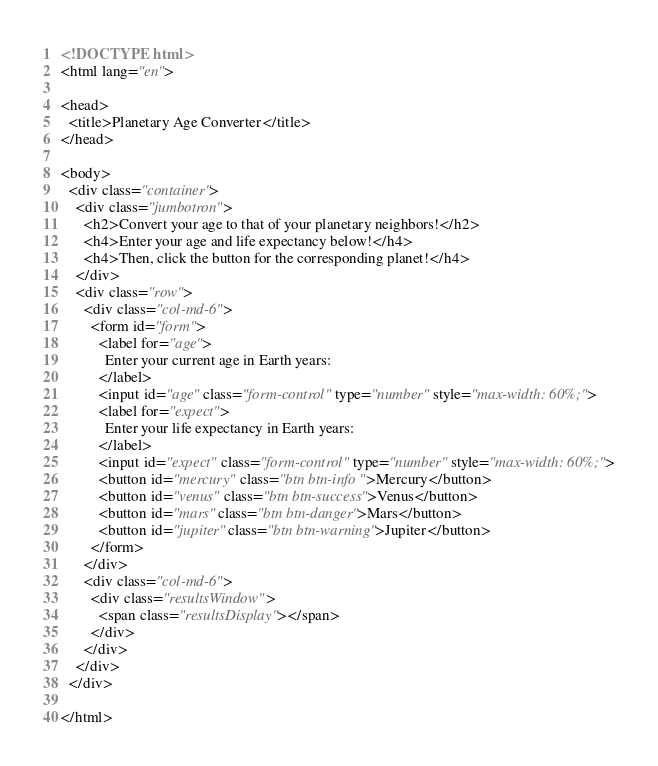Convert code to text. <code><loc_0><loc_0><loc_500><loc_500><_HTML_><!DOCTYPE html>
<html lang="en">

<head>
  <title>Planetary Age Converter</title>
</head>

<body>
  <div class="container">
    <div class="jumbotron">
      <h2>Convert your age to that of your planetary neighbors!</h2>
      <h4>Enter your age and life expectancy below!</h4>
      <h4>Then, click the button for the corresponding planet!</h4>
    </div>
    <div class="row">
      <div class="col-md-6">
        <form id="form">
          <label for="age">
            Enter your current age in Earth years:
          </label>
          <input id="age" class="form-control" type="number" style="max-width: 60%;">
          <label for="expect">
            Enter your life expectancy in Earth years:
          </label>
          <input id="expect" class="form-control" type="number" style="max-width: 60%;">
          <button id="mercury" class="btn btn-info ">Mercury</button>
          <button id="venus" class="btn btn-success">Venus</button>
          <button id="mars" class="btn btn-danger">Mars</button>
          <button id="jupiter" class="btn btn-warning">Jupiter</button>
        </form>
      </div>
      <div class="col-md-6">
        <div class="resultsWindow">
          <span class="resultsDisplay"></span>
        </div>
      </div>
    </div>
  </div>

</html></code> 